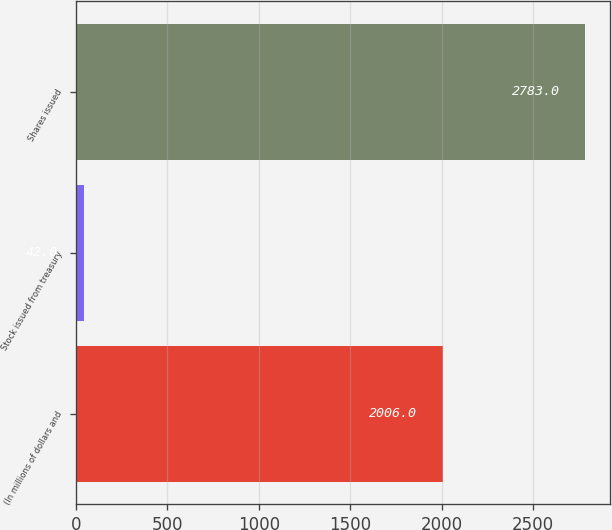Convert chart. <chart><loc_0><loc_0><loc_500><loc_500><bar_chart><fcel>(In millions of dollars and<fcel>Stock issued from treasury<fcel>Shares issued<nl><fcel>2006<fcel>42<fcel>2783<nl></chart> 